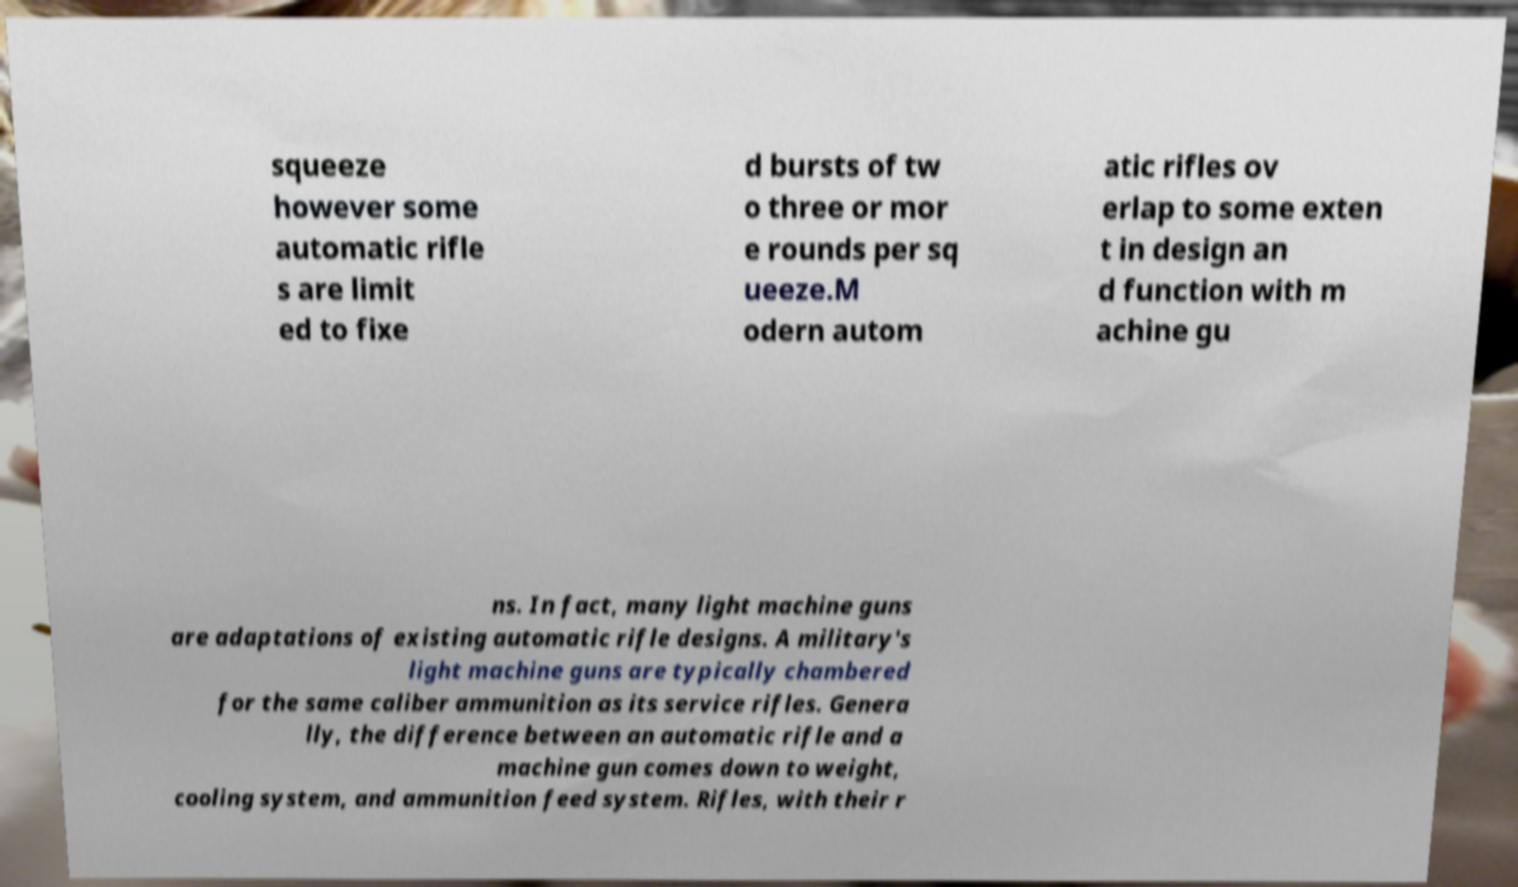Could you assist in decoding the text presented in this image and type it out clearly? squeeze however some automatic rifle s are limit ed to fixe d bursts of tw o three or mor e rounds per sq ueeze.M odern autom atic rifles ov erlap to some exten t in design an d function with m achine gu ns. In fact, many light machine guns are adaptations of existing automatic rifle designs. A military's light machine guns are typically chambered for the same caliber ammunition as its service rifles. Genera lly, the difference between an automatic rifle and a machine gun comes down to weight, cooling system, and ammunition feed system. Rifles, with their r 